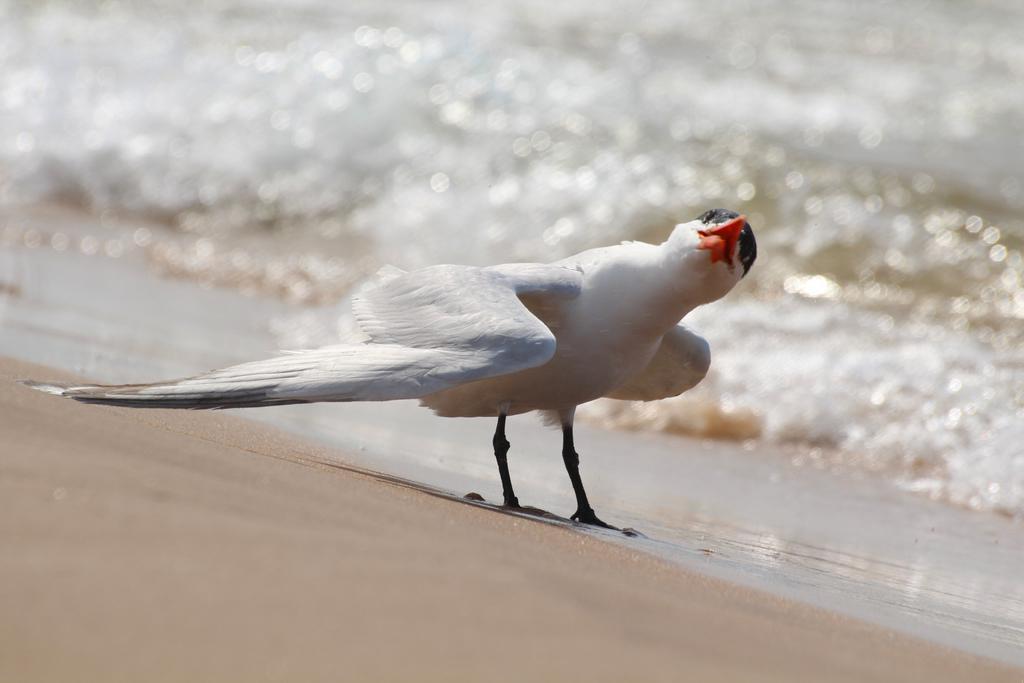Can you describe this image briefly? In this image in the center there is bird standing on the ground. In the background there is water. 